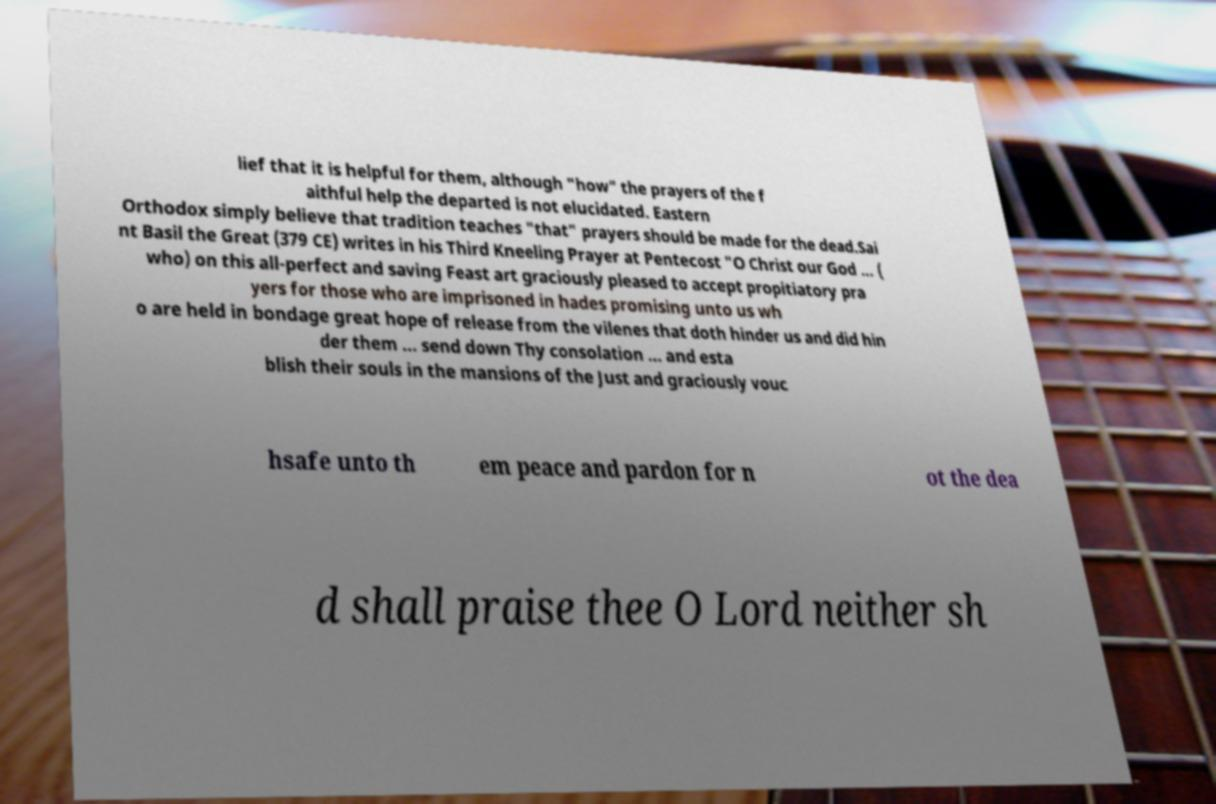For documentation purposes, I need the text within this image transcribed. Could you provide that? lief that it is helpful for them, although "how" the prayers of the f aithful help the departed is not elucidated. Eastern Orthodox simply believe that tradition teaches "that" prayers should be made for the dead.Sai nt Basil the Great (379 CE) writes in his Third Kneeling Prayer at Pentecost "O Christ our God ... ( who) on this all-perfect and saving Feast art graciously pleased to accept propitiatory pra yers for those who are imprisoned in hades promising unto us wh o are held in bondage great hope of release from the vilenes that doth hinder us and did hin der them ... send down Thy consolation ... and esta blish their souls in the mansions of the Just and graciously vouc hsafe unto th em peace and pardon for n ot the dea d shall praise thee O Lord neither sh 